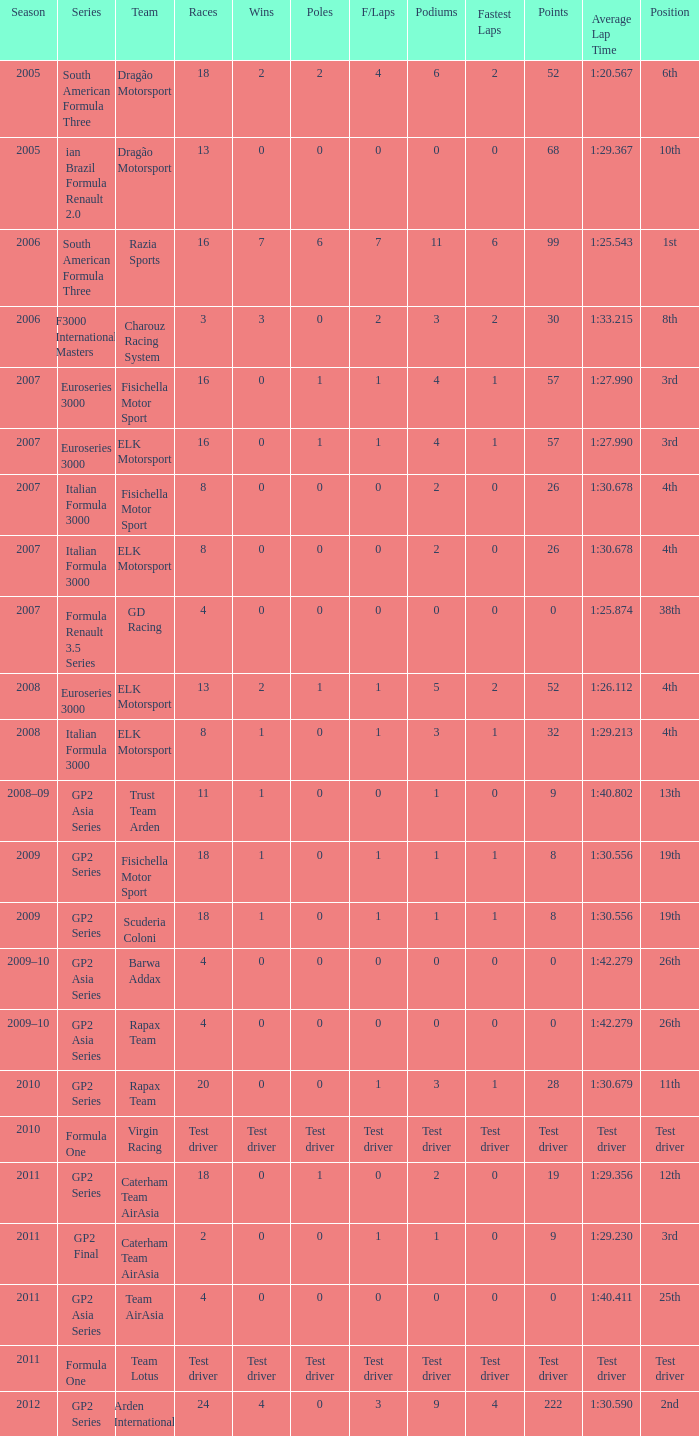What were the points in the year when his Wins were 0, his Podiums were 0, and he drove in 4 races? 0, 0, 0, 0. 